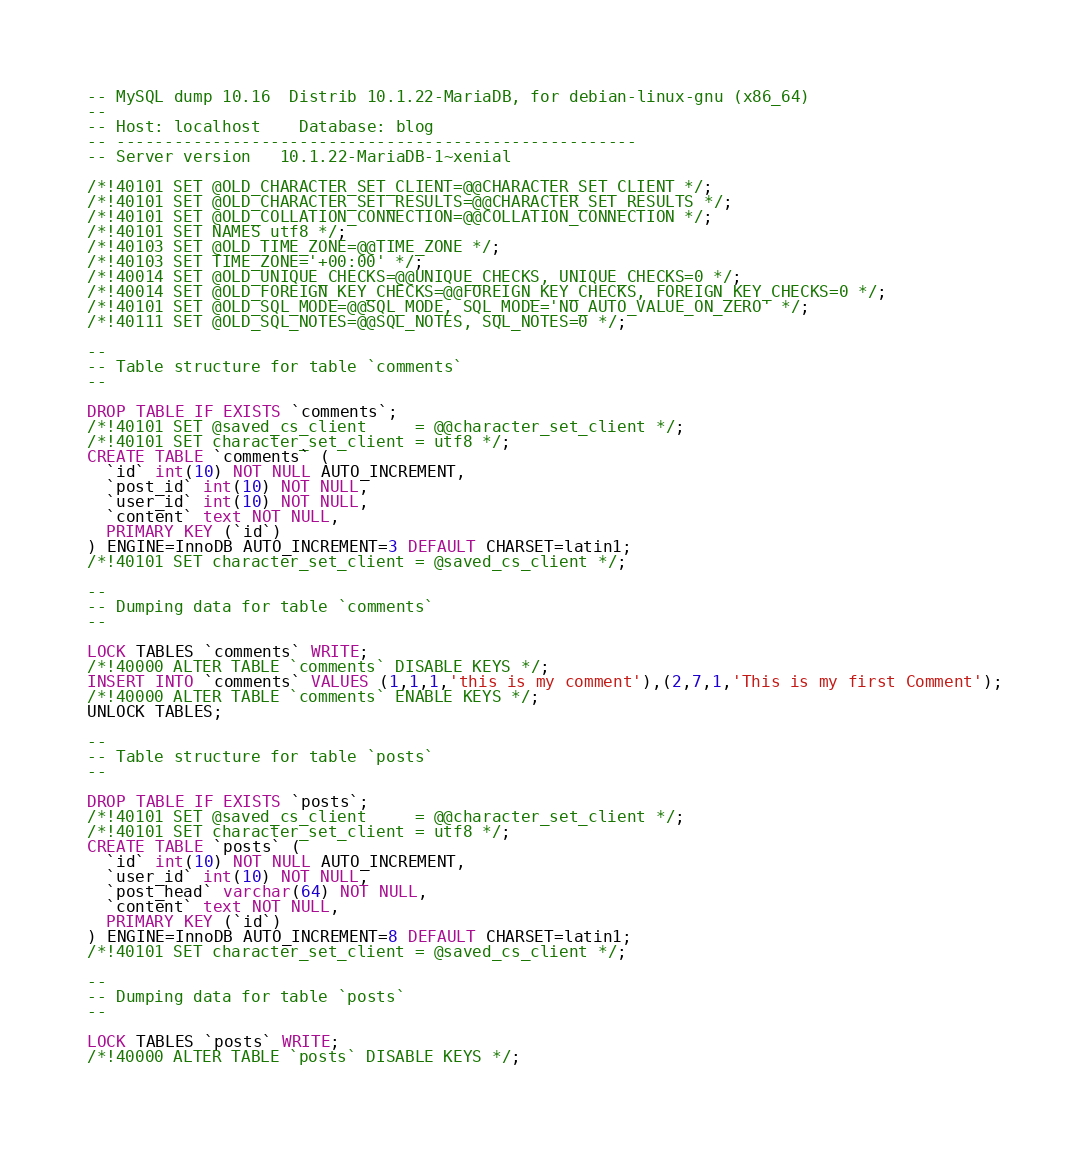<code> <loc_0><loc_0><loc_500><loc_500><_SQL_>-- MySQL dump 10.16  Distrib 10.1.22-MariaDB, for debian-linux-gnu (x86_64)
--
-- Host: localhost    Database: blog
-- ------------------------------------------------------
-- Server version	10.1.22-MariaDB-1~xenial

/*!40101 SET @OLD_CHARACTER_SET_CLIENT=@@CHARACTER_SET_CLIENT */;
/*!40101 SET @OLD_CHARACTER_SET_RESULTS=@@CHARACTER_SET_RESULTS */;
/*!40101 SET @OLD_COLLATION_CONNECTION=@@COLLATION_CONNECTION */;
/*!40101 SET NAMES utf8 */;
/*!40103 SET @OLD_TIME_ZONE=@@TIME_ZONE */;
/*!40103 SET TIME_ZONE='+00:00' */;
/*!40014 SET @OLD_UNIQUE_CHECKS=@@UNIQUE_CHECKS, UNIQUE_CHECKS=0 */;
/*!40014 SET @OLD_FOREIGN_KEY_CHECKS=@@FOREIGN_KEY_CHECKS, FOREIGN_KEY_CHECKS=0 */;
/*!40101 SET @OLD_SQL_MODE=@@SQL_MODE, SQL_MODE='NO_AUTO_VALUE_ON_ZERO' */;
/*!40111 SET @OLD_SQL_NOTES=@@SQL_NOTES, SQL_NOTES=0 */;

--
-- Table structure for table `comments`
--

DROP TABLE IF EXISTS `comments`;
/*!40101 SET @saved_cs_client     = @@character_set_client */;
/*!40101 SET character_set_client = utf8 */;
CREATE TABLE `comments` (
  `id` int(10) NOT NULL AUTO_INCREMENT,
  `post_id` int(10) NOT NULL,
  `user_id` int(10) NOT NULL,
  `content` text NOT NULL,
  PRIMARY KEY (`id`)
) ENGINE=InnoDB AUTO_INCREMENT=3 DEFAULT CHARSET=latin1;
/*!40101 SET character_set_client = @saved_cs_client */;

--
-- Dumping data for table `comments`
--

LOCK TABLES `comments` WRITE;
/*!40000 ALTER TABLE `comments` DISABLE KEYS */;
INSERT INTO `comments` VALUES (1,1,1,'this is my comment'),(2,7,1,'This is my first Comment');
/*!40000 ALTER TABLE `comments` ENABLE KEYS */;
UNLOCK TABLES;

--
-- Table structure for table `posts`
--

DROP TABLE IF EXISTS `posts`;
/*!40101 SET @saved_cs_client     = @@character_set_client */;
/*!40101 SET character_set_client = utf8 */;
CREATE TABLE `posts` (
  `id` int(10) NOT NULL AUTO_INCREMENT,
  `user_id` int(10) NOT NULL,
  `post_head` varchar(64) NOT NULL,
  `content` text NOT NULL,
  PRIMARY KEY (`id`)
) ENGINE=InnoDB AUTO_INCREMENT=8 DEFAULT CHARSET=latin1;
/*!40101 SET character_set_client = @saved_cs_client */;

--
-- Dumping data for table `posts`
--

LOCK TABLES `posts` WRITE;
/*!40000 ALTER TABLE `posts` DISABLE KEYS */;</code> 